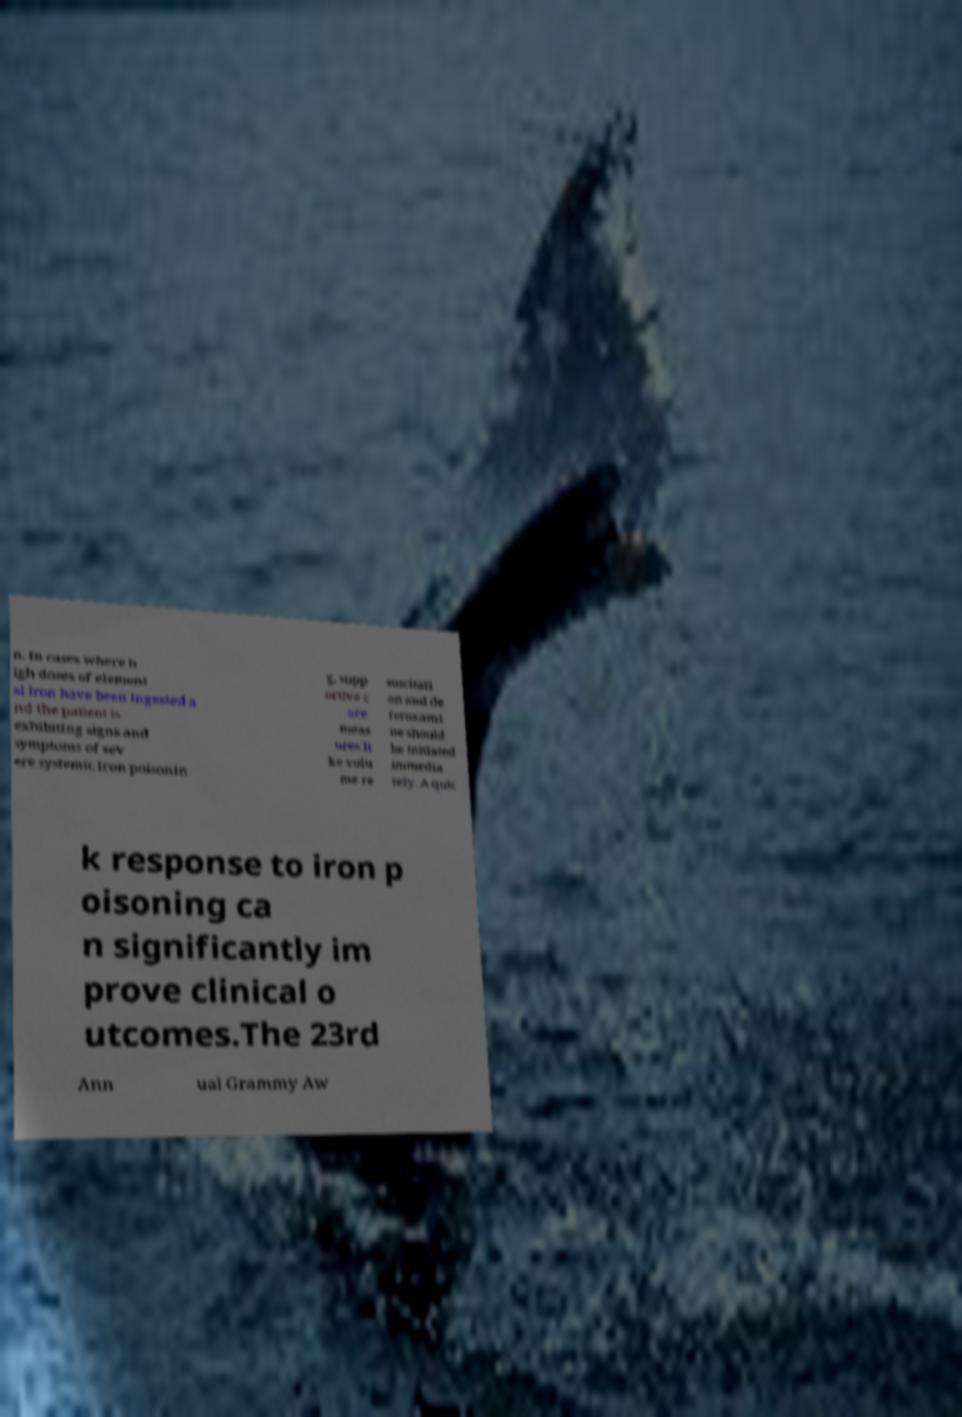Can you read and provide the text displayed in the image?This photo seems to have some interesting text. Can you extract and type it out for me? n. In cases where h igh doses of element al iron have been ingested a nd the patient is exhibiting signs and symptoms of sev ere systemic iron poisonin g, supp ortive c are meas ures li ke volu me re suscitati on and de feroxami ne should be initiated immedia tely. A quic k response to iron p oisoning ca n significantly im prove clinical o utcomes.The 23rd Ann ual Grammy Aw 